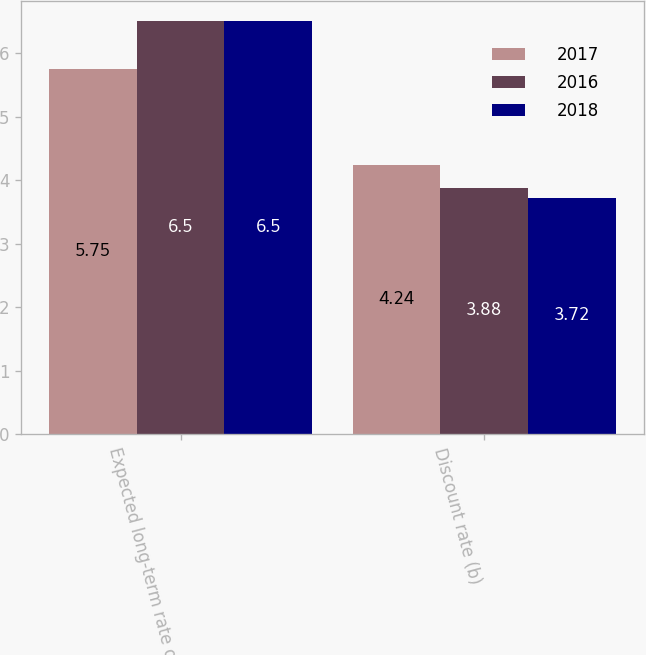Convert chart to OTSL. <chart><loc_0><loc_0><loc_500><loc_500><stacked_bar_chart><ecel><fcel>Expected long-term rate of<fcel>Discount rate (b)<nl><fcel>2017<fcel>5.75<fcel>4.24<nl><fcel>2016<fcel>6.5<fcel>3.88<nl><fcel>2018<fcel>6.5<fcel>3.72<nl></chart> 